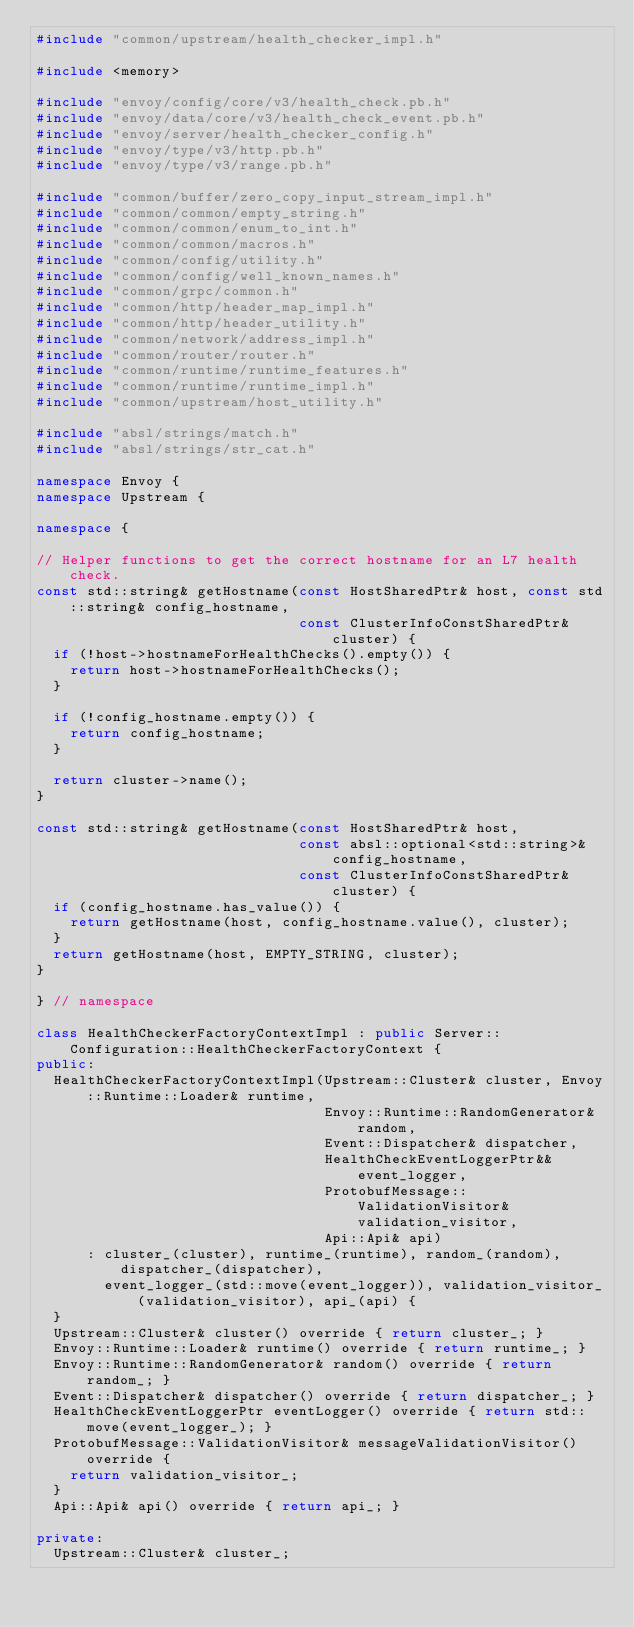Convert code to text. <code><loc_0><loc_0><loc_500><loc_500><_C++_>#include "common/upstream/health_checker_impl.h"

#include <memory>

#include "envoy/config/core/v3/health_check.pb.h"
#include "envoy/data/core/v3/health_check_event.pb.h"
#include "envoy/server/health_checker_config.h"
#include "envoy/type/v3/http.pb.h"
#include "envoy/type/v3/range.pb.h"

#include "common/buffer/zero_copy_input_stream_impl.h"
#include "common/common/empty_string.h"
#include "common/common/enum_to_int.h"
#include "common/common/macros.h"
#include "common/config/utility.h"
#include "common/config/well_known_names.h"
#include "common/grpc/common.h"
#include "common/http/header_map_impl.h"
#include "common/http/header_utility.h"
#include "common/network/address_impl.h"
#include "common/router/router.h"
#include "common/runtime/runtime_features.h"
#include "common/runtime/runtime_impl.h"
#include "common/upstream/host_utility.h"

#include "absl/strings/match.h"
#include "absl/strings/str_cat.h"

namespace Envoy {
namespace Upstream {

namespace {

// Helper functions to get the correct hostname for an L7 health check.
const std::string& getHostname(const HostSharedPtr& host, const std::string& config_hostname,
                               const ClusterInfoConstSharedPtr& cluster) {
  if (!host->hostnameForHealthChecks().empty()) {
    return host->hostnameForHealthChecks();
  }

  if (!config_hostname.empty()) {
    return config_hostname;
  }

  return cluster->name();
}

const std::string& getHostname(const HostSharedPtr& host,
                               const absl::optional<std::string>& config_hostname,
                               const ClusterInfoConstSharedPtr& cluster) {
  if (config_hostname.has_value()) {
    return getHostname(host, config_hostname.value(), cluster);
  }
  return getHostname(host, EMPTY_STRING, cluster);
}

} // namespace

class HealthCheckerFactoryContextImpl : public Server::Configuration::HealthCheckerFactoryContext {
public:
  HealthCheckerFactoryContextImpl(Upstream::Cluster& cluster, Envoy::Runtime::Loader& runtime,
                                  Envoy::Runtime::RandomGenerator& random,
                                  Event::Dispatcher& dispatcher,
                                  HealthCheckEventLoggerPtr&& event_logger,
                                  ProtobufMessage::ValidationVisitor& validation_visitor,
                                  Api::Api& api)
      : cluster_(cluster), runtime_(runtime), random_(random), dispatcher_(dispatcher),
        event_logger_(std::move(event_logger)), validation_visitor_(validation_visitor), api_(api) {
  }
  Upstream::Cluster& cluster() override { return cluster_; }
  Envoy::Runtime::Loader& runtime() override { return runtime_; }
  Envoy::Runtime::RandomGenerator& random() override { return random_; }
  Event::Dispatcher& dispatcher() override { return dispatcher_; }
  HealthCheckEventLoggerPtr eventLogger() override { return std::move(event_logger_); }
  ProtobufMessage::ValidationVisitor& messageValidationVisitor() override {
    return validation_visitor_;
  }
  Api::Api& api() override { return api_; }

private:
  Upstream::Cluster& cluster_;</code> 